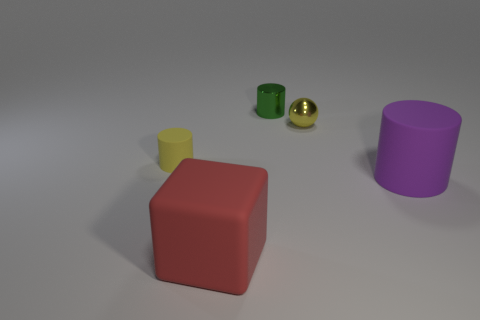Subtract all purple cylinders. How many cylinders are left? 2 Subtract all yellow cylinders. How many cylinders are left? 2 Subtract all cylinders. How many objects are left? 2 Add 2 tiny cyan cubes. How many objects exist? 7 Subtract 1 cubes. How many cubes are left? 0 Subtract all green metallic cylinders. Subtract all green cylinders. How many objects are left? 3 Add 5 tiny yellow objects. How many tiny yellow objects are left? 7 Add 2 big rubber cylinders. How many big rubber cylinders exist? 3 Subtract 0 blue spheres. How many objects are left? 5 Subtract all purple cylinders. Subtract all green blocks. How many cylinders are left? 2 